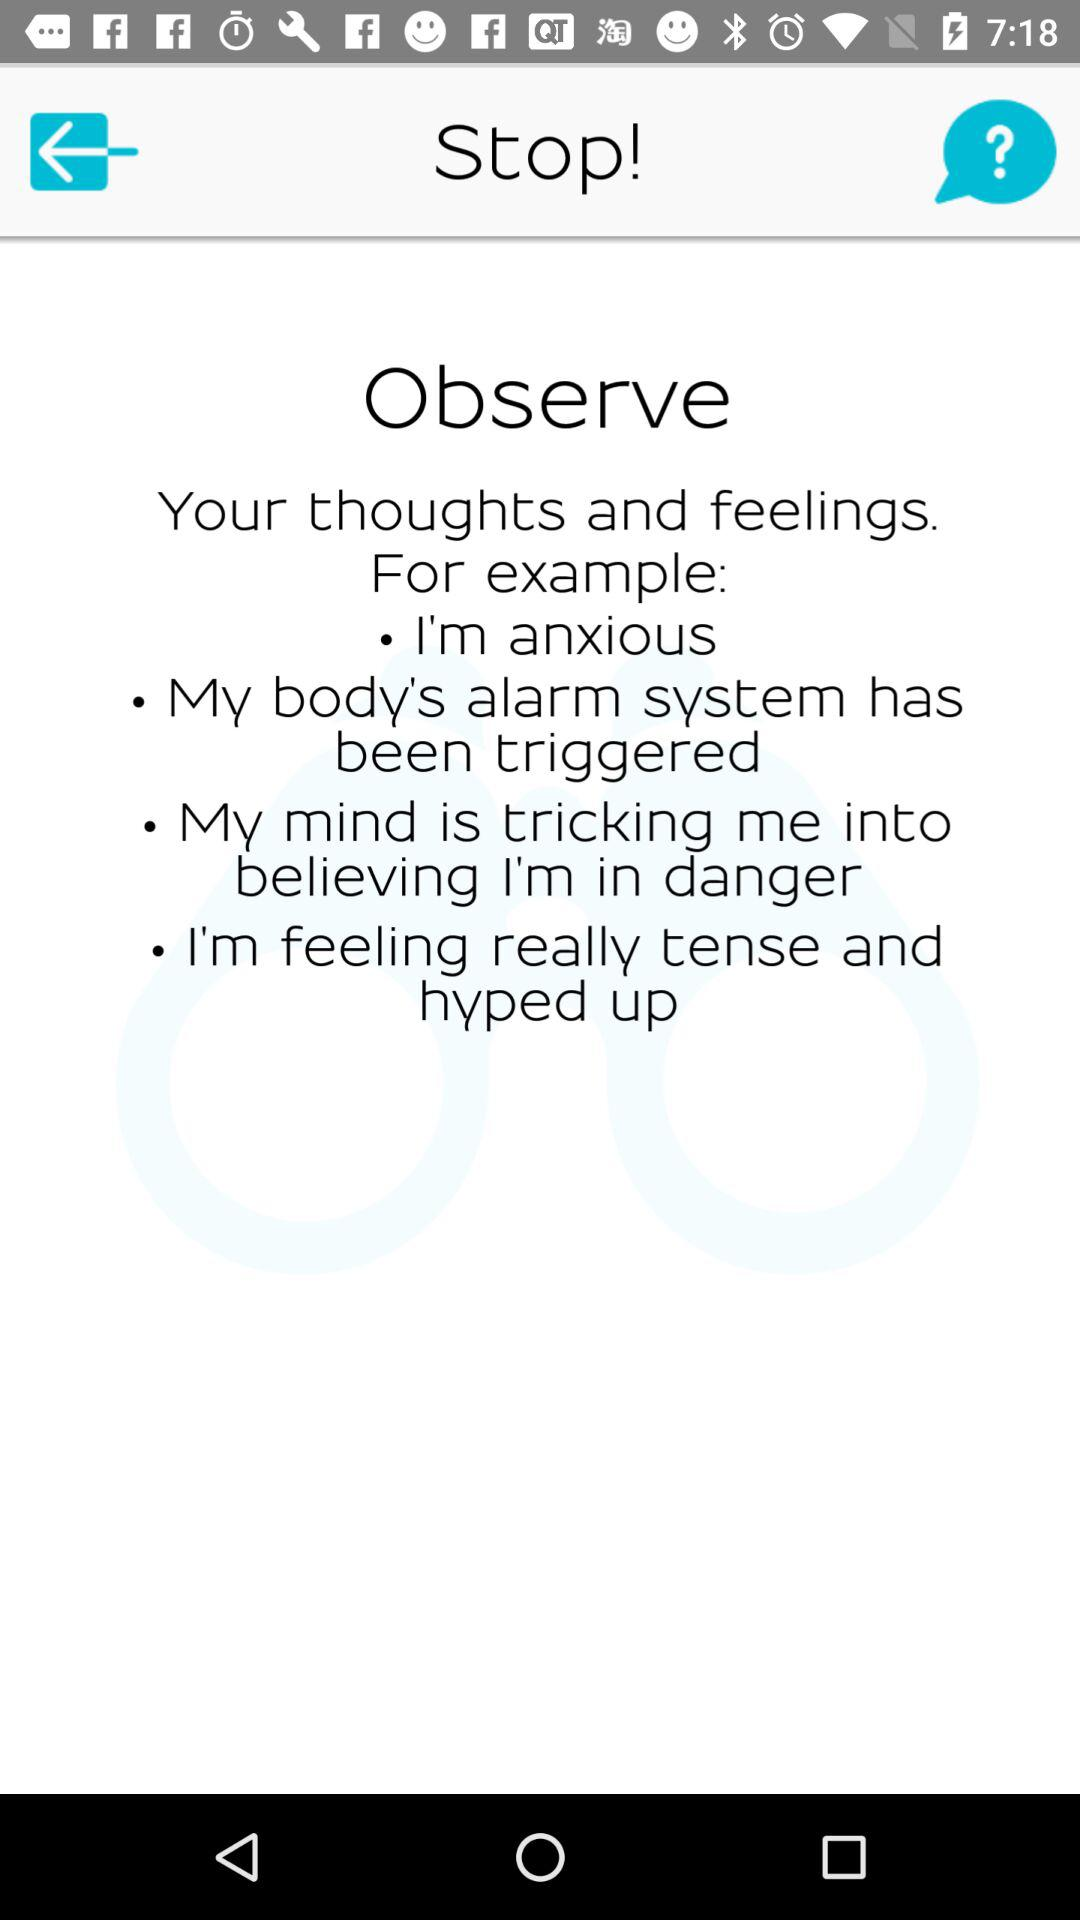How many examples are there for how to observe thoughts and feelings?
Answer the question using a single word or phrase. 4 